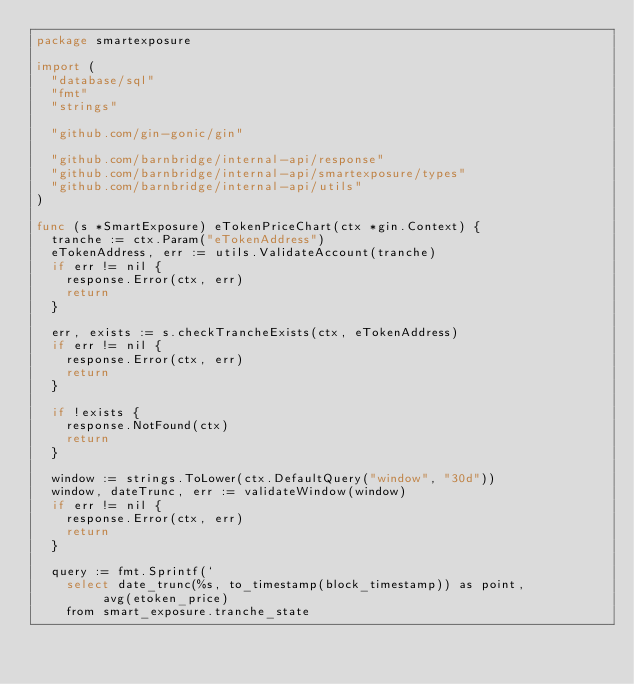Convert code to text. <code><loc_0><loc_0><loc_500><loc_500><_Go_>package smartexposure

import (
	"database/sql"
	"fmt"
	"strings"

	"github.com/gin-gonic/gin"

	"github.com/barnbridge/internal-api/response"
	"github.com/barnbridge/internal-api/smartexposure/types"
	"github.com/barnbridge/internal-api/utils"
)

func (s *SmartExposure) eTokenPriceChart(ctx *gin.Context) {
	tranche := ctx.Param("eTokenAddress")
	eTokenAddress, err := utils.ValidateAccount(tranche)
	if err != nil {
		response.Error(ctx, err)
		return
	}

	err, exists := s.checkTrancheExists(ctx, eTokenAddress)
	if err != nil {
		response.Error(ctx, err)
		return
	}

	if !exists {
		response.NotFound(ctx)
		return
	}

	window := strings.ToLower(ctx.DefaultQuery("window", "30d"))
	window, dateTrunc, err := validateWindow(window)
	if err != nil {
		response.Error(ctx, err)
		return
	}

	query := fmt.Sprintf(`
		select date_trunc(%s, to_timestamp(block_timestamp)) as point,
			   avg(etoken_price)
		from smart_exposure.tranche_state</code> 